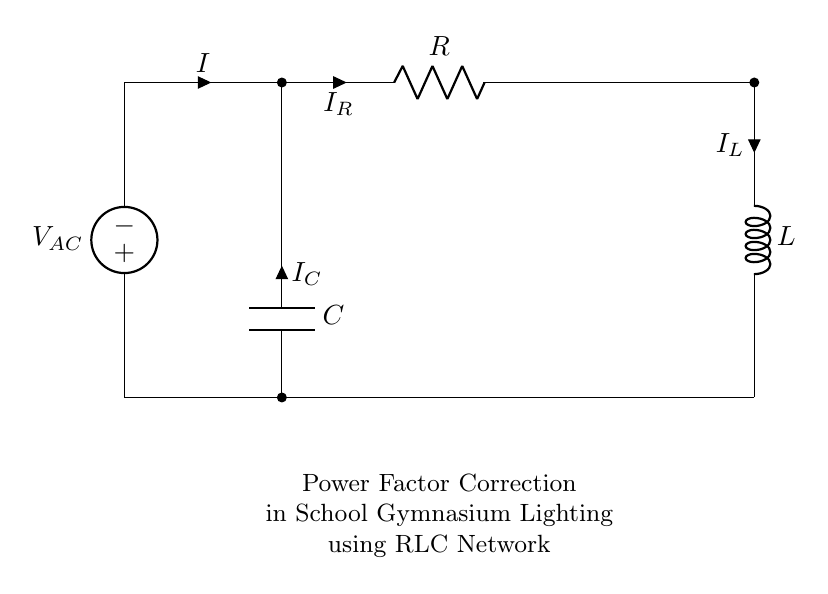What components are present in the circuit? The circuit consists of a voltage source, resistor, inductor, and capacitor. Each component plays a distinct role in power factor correction.
Answer: voltage source, resistor, inductor, capacitor What is the purpose of the inductor in this circuit? The inductor stores energy in a magnetic field when current flows through it, contributing to the reactive power in the circuit, which helps correct the power factor.
Answer: to store energy What is the role of the resistor in power factor correction? The resistor dissipates energy in the form of heat and helps to improve the overall power factor by providing a real power component in the circuit.
Answer: dissipates energy What type of circuit is represented by this diagram? The circuit is a parallel RLC circuit, as it demonstrates the arrangement of the resistor, inductor, and capacitor connected in a parallel configuration to correct the power factor.
Answer: parallel RLC circuit What happens to the total current in the circuit? The total current is the sum of the individual currents through the resistor, inductor, and capacitor, illustrating the concept of current division in parallel circuits.
Answer: sum of individual currents How does a capacitor affect the power factor in this circuit? The capacitor provides leading reactive power, which compensates for the lagging reactive power of the inductor, thus improving the power factor.
Answer: provides leading reactive power What is the phase relationship of voltage and current in an RLC circuit? In an RLC circuit, voltage and current are phase-shifted, depending on the components; the resistor keeps them in phase, while the inductor and capacitor create a phase difference.
Answer: phase-shifted 